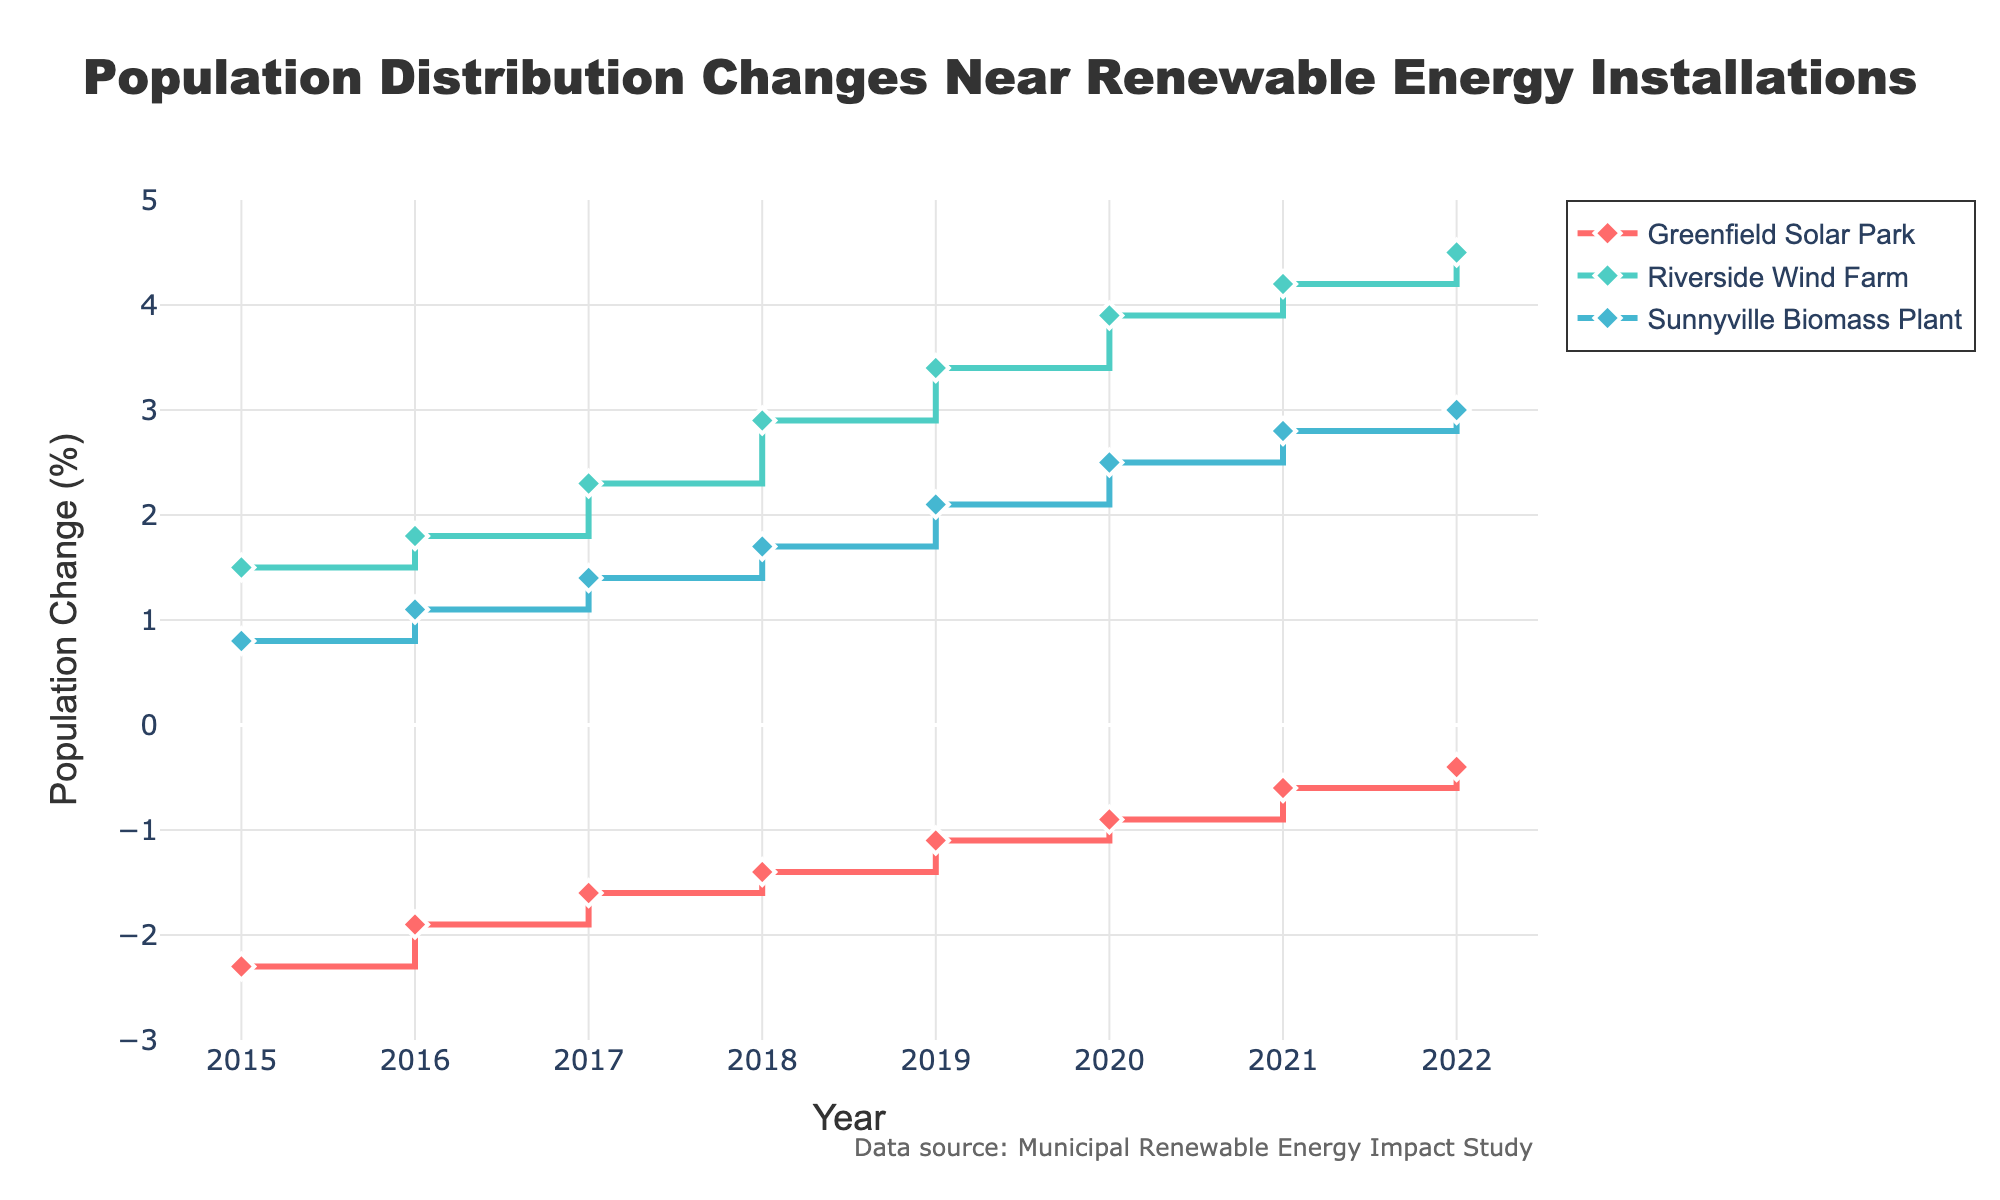What is the title of the figure? The title is prominently displayed at the top of the figure, centered. It reads: "Population Distribution Changes Near Renewable Energy Installations".
Answer: Population Distribution Changes Near Renewable Energy Installations What is the population change percentage for Riverside Wind Farm in 2018? Locate the line for Riverside Wind Farm, marked in a specific color, at the year 2018 on the x-axis. The y-axis value for this point is 2.9.
Answer: 2.9 Which location had a negative population change in every year from 2015 to 2022? Look for the line that stays below the 0% mark on the y-axis throughout the entire timeline. The Greenfield Solar Park line exhibits this trend.
Answer: Greenfield Solar Park In which year did Sunnyville Biomass Plant reach a population change of 2.1%? Find the 2.1% mark on the y-axis and trace it horizontally to intersect with the Sunnyville Biomass Plant line. This occurs in 2019.
Answer: 2019 How does the trend in population change for Riverside Wind Farm compare with Greenfield Solar Park from 2015 to 2022? Observe both lines from 2015 to 2022. Riverside Wind Farm shows a consistent increase in population change each year, while Greenfield Solar Park shows a consistent decrease (negative population change becoming less negative) each year.
Answer: Riverside Wind Farm is consistently increasing, while Greenfield Solar Park is consistently decreasing What is the average population change for Sunnyville Biomass Plant from 2015 to 2022? List the population changes for Sunnyville Biomass Plant for each year: (0.8, 1.1, 1.4, 1.7, 2.1, 2.5, 2.8, 3.0). Sum these values (0.8 + 1.1 + 1.4 + 1.7 + 2.1 + 2.5 + 2.8 + 3.0 = 15.4) and divide by the number of years (8): 15.4 / 8 = 1.925.
Answer: 1.925 What is the difference in population change between the highest and the lowest points for Riverside Wind Farm? Identify the highest and lowest population change values for Riverside Wind Farm: 4.5% in 2022 and 1.5% in 2015. Subtract the lowest from the highest: 4.5 - 1.5 = 3.0.
Answer: 3.0 Which installation shows the steepest increase in population change over a single year? Look at the steepness of the slopes for any one-year period for all installations. The steepest increase is observed for Riverside Wind Farm between 2017 (2.3%) and 2018 (2.9%), which is an increase of 0.6%.
Answer: Riverside Wind Farm Which year shows the smallest absolute population change for Greenfield Solar Park? Check the population change for Greenfield Solar Park each year and find the smallest absolute value. In 2022, the population change is -0.4%.
Answer: 2022 What is the total population change for Riverside Wind Farm from 2015 to 2022? List the population changes for Riverside Wind Farm for each year: (1.5, 1.8, 2.3, 2.9, 3.4, 3.9, 4.2, 4.5). Sum these values: 1.5 + 1.8 + 2.3 + 2.9 + 3.4 + 3.9 + 4.2 + 4.5 = 24.5.
Answer: 24.5 